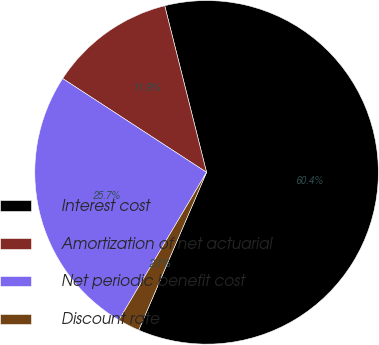<chart> <loc_0><loc_0><loc_500><loc_500><pie_chart><fcel>Interest cost<fcel>Amortization of net actuarial<fcel>Net periodic benefit cost<fcel>Discount rate<nl><fcel>60.38%<fcel>11.89%<fcel>25.67%<fcel>2.06%<nl></chart> 